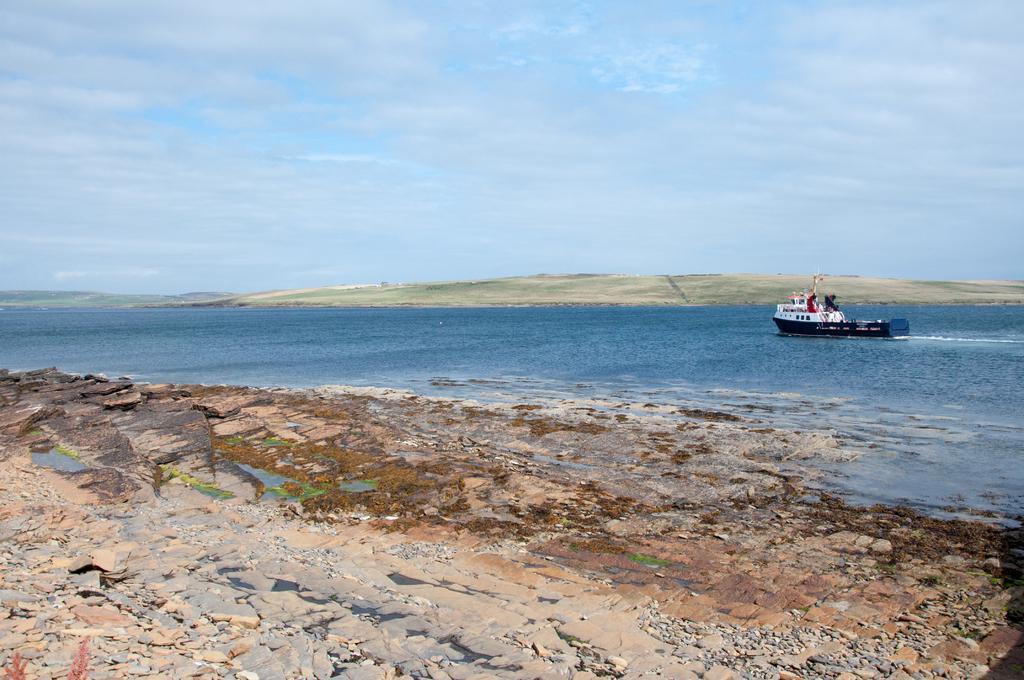Could you give a brief overview of what you see in this image? This image is taken at the seashore. At the center of the image we can see there is a boat on the river. In the background there is a sky. 